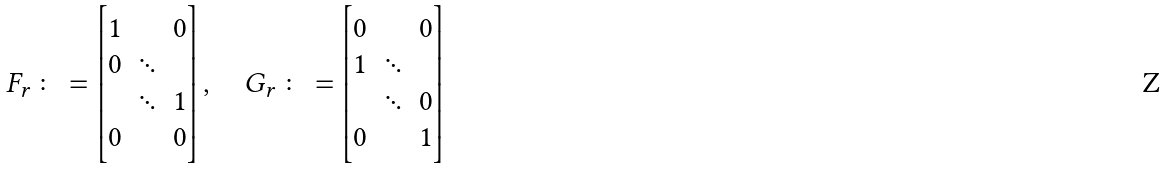Convert formula to latex. <formula><loc_0><loc_0><loc_500><loc_500>F _ { r } \colon = \begin{bmatrix} 1 & & 0 \\ 0 & \ddots & \\ & \ddots & 1 \\ 0 & & 0 \end{bmatrix} , \quad G _ { r } \colon = \begin{bmatrix} 0 & & 0 \\ 1 & \ddots & \\ & \ddots & 0 \\ 0 & & 1 \end{bmatrix}</formula> 